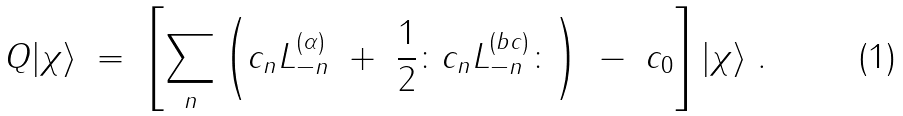Convert formula to latex. <formula><loc_0><loc_0><loc_500><loc_500>Q | \chi \rangle \ = \ \left [ \sum _ { n } \left ( c _ { n } L _ { - n } ^ { ( \alpha ) } \ + \ \frac { 1 } { 2 } \colon c _ { n } L _ { - n } ^ { ( b c ) } \colon \right ) \ - \ c _ { 0 } \right ] | \chi \rangle \ .</formula> 